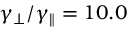Convert formula to latex. <formula><loc_0><loc_0><loc_500><loc_500>\gamma _ { \perp } / \gamma _ { \| } = 1 0 . 0</formula> 